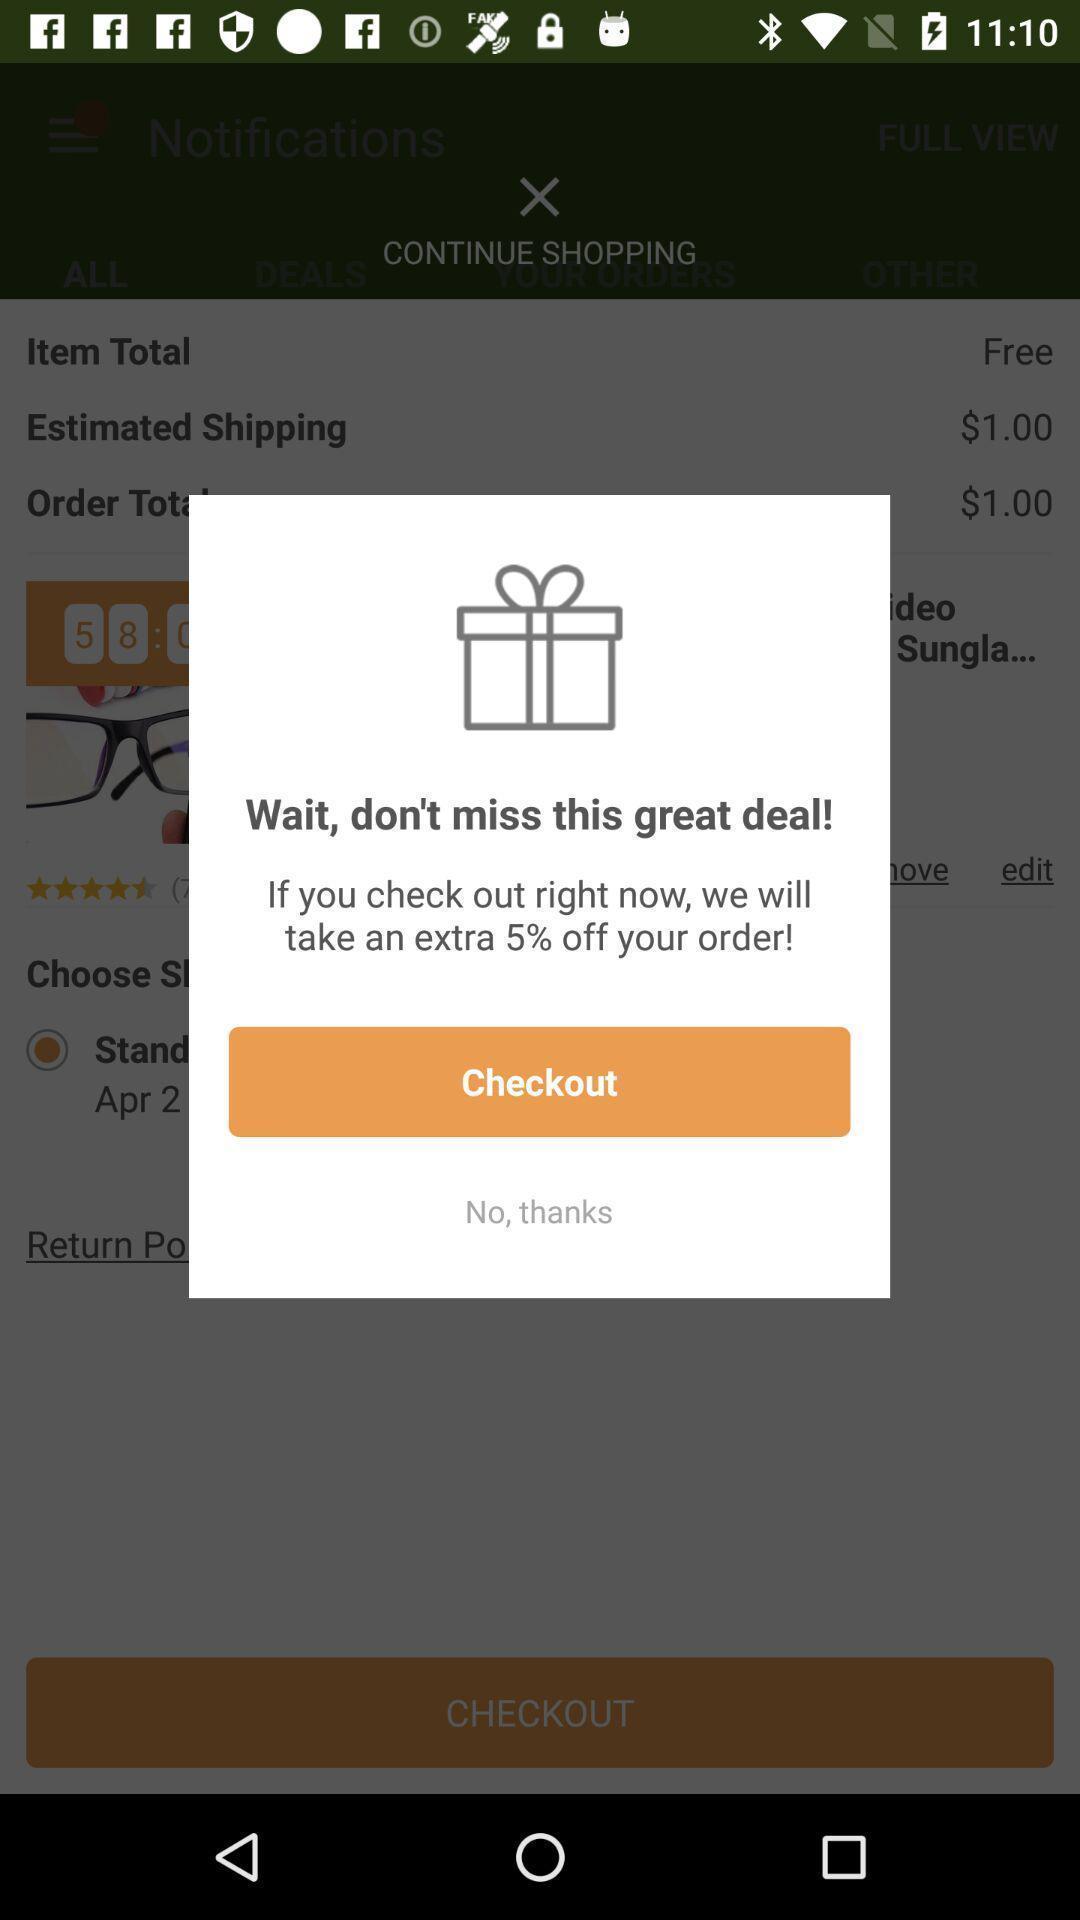Describe this image in words. Pop up to checkout an order in shopping application. 